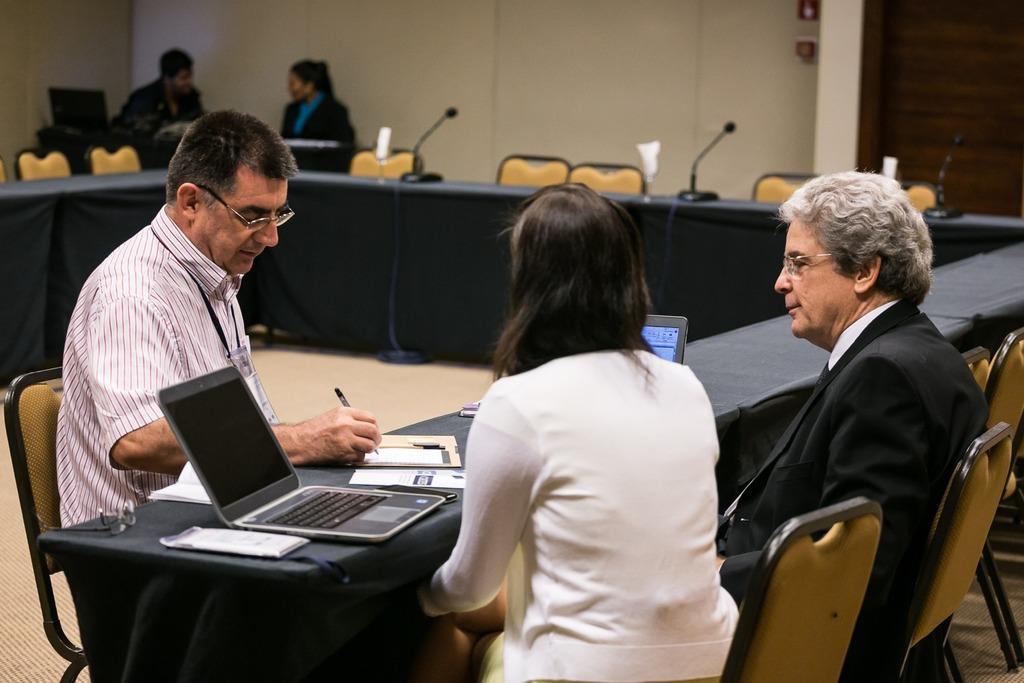Describe this image in one or two sentences. On the right side, there is a woman in a white color jacket, sitting on a chair. Beside her, there is another person sitting on a chair in front of a table, on which there are two laptops and books arranged. On the left side, there is a person in a shirt, wearing a badge and writing something in a book. In the background, there are three mics arranged on the table, beside this table, there are chairs arranged, there are two persons sitting, there is a laptop and other objects on the table and there is a wall. 